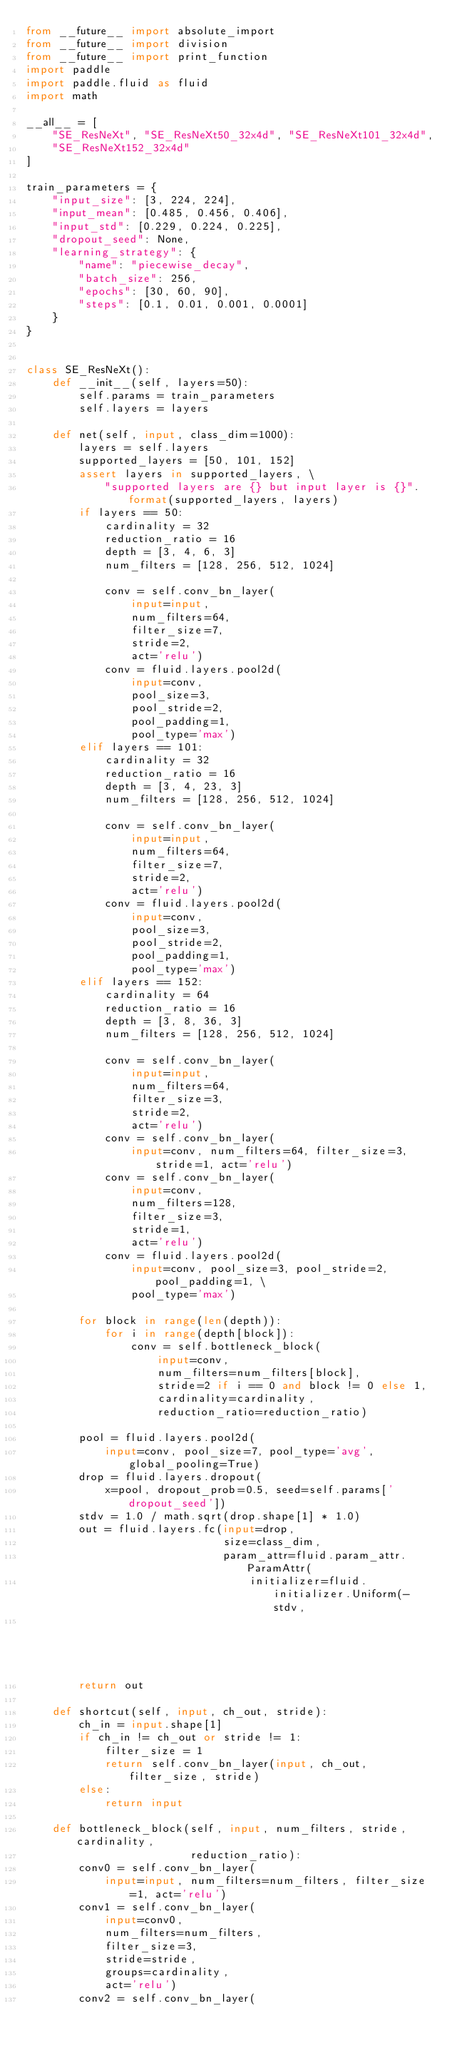<code> <loc_0><loc_0><loc_500><loc_500><_Python_>from __future__ import absolute_import
from __future__ import division
from __future__ import print_function
import paddle
import paddle.fluid as fluid
import math

__all__ = [
    "SE_ResNeXt", "SE_ResNeXt50_32x4d", "SE_ResNeXt101_32x4d",
    "SE_ResNeXt152_32x4d"
]

train_parameters = {
    "input_size": [3, 224, 224],
    "input_mean": [0.485, 0.456, 0.406],
    "input_std": [0.229, 0.224, 0.225],
    "dropout_seed": None,
    "learning_strategy": {
        "name": "piecewise_decay",
        "batch_size": 256,
        "epochs": [30, 60, 90],
        "steps": [0.1, 0.01, 0.001, 0.0001]
    }
}


class SE_ResNeXt():
    def __init__(self, layers=50):
        self.params = train_parameters
        self.layers = layers

    def net(self, input, class_dim=1000):
        layers = self.layers
        supported_layers = [50, 101, 152]
        assert layers in supported_layers, \
            "supported layers are {} but input layer is {}".format(supported_layers, layers)
        if layers == 50:
            cardinality = 32
            reduction_ratio = 16
            depth = [3, 4, 6, 3]
            num_filters = [128, 256, 512, 1024]

            conv = self.conv_bn_layer(
                input=input,
                num_filters=64,
                filter_size=7,
                stride=2,
                act='relu')
            conv = fluid.layers.pool2d(
                input=conv,
                pool_size=3,
                pool_stride=2,
                pool_padding=1,
                pool_type='max')
        elif layers == 101:
            cardinality = 32
            reduction_ratio = 16
            depth = [3, 4, 23, 3]
            num_filters = [128, 256, 512, 1024]

            conv = self.conv_bn_layer(
                input=input,
                num_filters=64,
                filter_size=7,
                stride=2,
                act='relu')
            conv = fluid.layers.pool2d(
                input=conv,
                pool_size=3,
                pool_stride=2,
                pool_padding=1,
                pool_type='max')
        elif layers == 152:
            cardinality = 64
            reduction_ratio = 16
            depth = [3, 8, 36, 3]
            num_filters = [128, 256, 512, 1024]

            conv = self.conv_bn_layer(
                input=input,
                num_filters=64,
                filter_size=3,
                stride=2,
                act='relu')
            conv = self.conv_bn_layer(
                input=conv, num_filters=64, filter_size=3, stride=1, act='relu')
            conv = self.conv_bn_layer(
                input=conv,
                num_filters=128,
                filter_size=3,
                stride=1,
                act='relu')
            conv = fluid.layers.pool2d(
                input=conv, pool_size=3, pool_stride=2, pool_padding=1, \
                pool_type='max')

        for block in range(len(depth)):
            for i in range(depth[block]):
                conv = self.bottleneck_block(
                    input=conv,
                    num_filters=num_filters[block],
                    stride=2 if i == 0 and block != 0 else 1,
                    cardinality=cardinality,
                    reduction_ratio=reduction_ratio)

        pool = fluid.layers.pool2d(
            input=conv, pool_size=7, pool_type='avg', global_pooling=True)
        drop = fluid.layers.dropout(
            x=pool, dropout_prob=0.5, seed=self.params['dropout_seed'])
        stdv = 1.0 / math.sqrt(drop.shape[1] * 1.0)
        out = fluid.layers.fc(input=drop,
                              size=class_dim,
                              param_attr=fluid.param_attr.ParamAttr(
                                  initializer=fluid.initializer.Uniform(-stdv,
                                                                        stdv)))
        return out

    def shortcut(self, input, ch_out, stride):
        ch_in = input.shape[1]
        if ch_in != ch_out or stride != 1:
            filter_size = 1
            return self.conv_bn_layer(input, ch_out, filter_size, stride)
        else:
            return input

    def bottleneck_block(self, input, num_filters, stride, cardinality,
                         reduction_ratio):
        conv0 = self.conv_bn_layer(
            input=input, num_filters=num_filters, filter_size=1, act='relu')
        conv1 = self.conv_bn_layer(
            input=conv0,
            num_filters=num_filters,
            filter_size=3,
            stride=stride,
            groups=cardinality,
            act='relu')
        conv2 = self.conv_bn_layer(</code> 